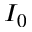<formula> <loc_0><loc_0><loc_500><loc_500>I _ { 0 }</formula> 